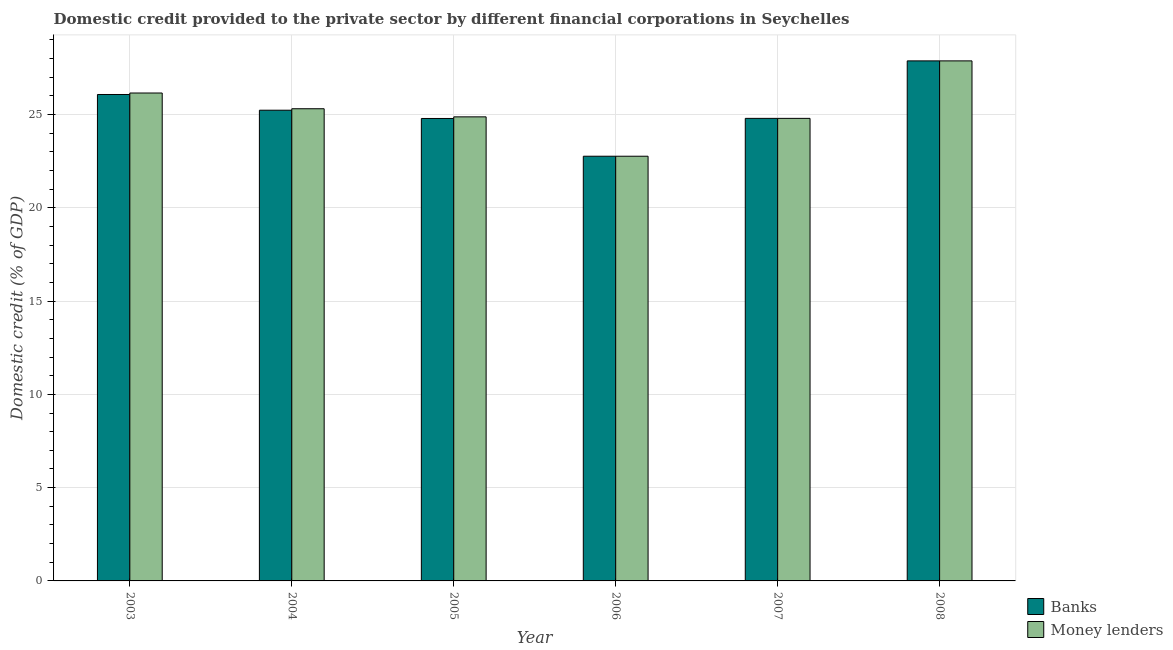How many different coloured bars are there?
Provide a succinct answer. 2. How many groups of bars are there?
Provide a succinct answer. 6. Are the number of bars per tick equal to the number of legend labels?
Your answer should be very brief. Yes. Are the number of bars on each tick of the X-axis equal?
Your answer should be compact. Yes. What is the domestic credit provided by banks in 2007?
Your answer should be compact. 24.79. Across all years, what is the maximum domestic credit provided by money lenders?
Keep it short and to the point. 27.88. Across all years, what is the minimum domestic credit provided by banks?
Your answer should be very brief. 22.76. In which year was the domestic credit provided by banks maximum?
Provide a short and direct response. 2008. In which year was the domestic credit provided by money lenders minimum?
Give a very brief answer. 2006. What is the total domestic credit provided by money lenders in the graph?
Make the answer very short. 151.77. What is the difference between the domestic credit provided by money lenders in 2005 and that in 2006?
Give a very brief answer. 2.11. What is the difference between the domestic credit provided by money lenders in 2006 and the domestic credit provided by banks in 2004?
Offer a very short reply. -2.55. What is the average domestic credit provided by banks per year?
Keep it short and to the point. 25.25. In the year 2004, what is the difference between the domestic credit provided by banks and domestic credit provided by money lenders?
Provide a succinct answer. 0. In how many years, is the domestic credit provided by money lenders greater than 7 %?
Your answer should be very brief. 6. What is the ratio of the domestic credit provided by banks in 2006 to that in 2007?
Your answer should be very brief. 0.92. Is the domestic credit provided by banks in 2006 less than that in 2008?
Give a very brief answer. Yes. What is the difference between the highest and the second highest domestic credit provided by money lenders?
Provide a short and direct response. 1.72. What is the difference between the highest and the lowest domestic credit provided by banks?
Make the answer very short. 5.11. Is the sum of the domestic credit provided by money lenders in 2004 and 2006 greater than the maximum domestic credit provided by banks across all years?
Give a very brief answer. Yes. What does the 1st bar from the left in 2003 represents?
Ensure brevity in your answer.  Banks. What does the 2nd bar from the right in 2003 represents?
Provide a short and direct response. Banks. Are the values on the major ticks of Y-axis written in scientific E-notation?
Make the answer very short. No. How many legend labels are there?
Provide a short and direct response. 2. What is the title of the graph?
Your response must be concise. Domestic credit provided to the private sector by different financial corporations in Seychelles. What is the label or title of the X-axis?
Make the answer very short. Year. What is the label or title of the Y-axis?
Ensure brevity in your answer.  Domestic credit (% of GDP). What is the Domestic credit (% of GDP) of Banks in 2003?
Offer a terse response. 26.07. What is the Domestic credit (% of GDP) of Money lenders in 2003?
Your answer should be very brief. 26.15. What is the Domestic credit (% of GDP) in Banks in 2004?
Give a very brief answer. 25.23. What is the Domestic credit (% of GDP) of Money lenders in 2004?
Your response must be concise. 25.31. What is the Domestic credit (% of GDP) in Banks in 2005?
Offer a very short reply. 24.79. What is the Domestic credit (% of GDP) in Money lenders in 2005?
Provide a succinct answer. 24.88. What is the Domestic credit (% of GDP) in Banks in 2006?
Offer a very short reply. 22.76. What is the Domestic credit (% of GDP) in Money lenders in 2006?
Offer a very short reply. 22.76. What is the Domestic credit (% of GDP) of Banks in 2007?
Your response must be concise. 24.79. What is the Domestic credit (% of GDP) in Money lenders in 2007?
Your response must be concise. 24.79. What is the Domestic credit (% of GDP) in Banks in 2008?
Keep it short and to the point. 27.88. What is the Domestic credit (% of GDP) of Money lenders in 2008?
Keep it short and to the point. 27.88. Across all years, what is the maximum Domestic credit (% of GDP) of Banks?
Give a very brief answer. 27.88. Across all years, what is the maximum Domestic credit (% of GDP) of Money lenders?
Provide a succinct answer. 27.88. Across all years, what is the minimum Domestic credit (% of GDP) of Banks?
Your answer should be very brief. 22.76. Across all years, what is the minimum Domestic credit (% of GDP) of Money lenders?
Give a very brief answer. 22.76. What is the total Domestic credit (% of GDP) in Banks in the graph?
Provide a short and direct response. 151.53. What is the total Domestic credit (% of GDP) in Money lenders in the graph?
Make the answer very short. 151.77. What is the difference between the Domestic credit (% of GDP) of Banks in 2003 and that in 2004?
Your answer should be very brief. 0.84. What is the difference between the Domestic credit (% of GDP) of Money lenders in 2003 and that in 2004?
Offer a terse response. 0.84. What is the difference between the Domestic credit (% of GDP) in Banks in 2003 and that in 2005?
Offer a terse response. 1.29. What is the difference between the Domestic credit (% of GDP) of Money lenders in 2003 and that in 2005?
Provide a succinct answer. 1.28. What is the difference between the Domestic credit (% of GDP) of Banks in 2003 and that in 2006?
Your response must be concise. 3.31. What is the difference between the Domestic credit (% of GDP) in Money lenders in 2003 and that in 2006?
Make the answer very short. 3.39. What is the difference between the Domestic credit (% of GDP) in Banks in 2003 and that in 2007?
Offer a very short reply. 1.28. What is the difference between the Domestic credit (% of GDP) of Money lenders in 2003 and that in 2007?
Your answer should be compact. 1.36. What is the difference between the Domestic credit (% of GDP) of Banks in 2003 and that in 2008?
Keep it short and to the point. -1.8. What is the difference between the Domestic credit (% of GDP) of Money lenders in 2003 and that in 2008?
Your answer should be compact. -1.72. What is the difference between the Domestic credit (% of GDP) in Banks in 2004 and that in 2005?
Your answer should be compact. 0.44. What is the difference between the Domestic credit (% of GDP) in Money lenders in 2004 and that in 2005?
Provide a succinct answer. 0.43. What is the difference between the Domestic credit (% of GDP) of Banks in 2004 and that in 2006?
Offer a terse response. 2.47. What is the difference between the Domestic credit (% of GDP) of Money lenders in 2004 and that in 2006?
Offer a very short reply. 2.55. What is the difference between the Domestic credit (% of GDP) of Banks in 2004 and that in 2007?
Ensure brevity in your answer.  0.44. What is the difference between the Domestic credit (% of GDP) of Money lenders in 2004 and that in 2007?
Your answer should be compact. 0.52. What is the difference between the Domestic credit (% of GDP) in Banks in 2004 and that in 2008?
Provide a short and direct response. -2.64. What is the difference between the Domestic credit (% of GDP) in Money lenders in 2004 and that in 2008?
Provide a succinct answer. -2.57. What is the difference between the Domestic credit (% of GDP) of Banks in 2005 and that in 2006?
Offer a very short reply. 2.02. What is the difference between the Domestic credit (% of GDP) in Money lenders in 2005 and that in 2006?
Your answer should be compact. 2.11. What is the difference between the Domestic credit (% of GDP) of Banks in 2005 and that in 2007?
Provide a short and direct response. -0.01. What is the difference between the Domestic credit (% of GDP) of Money lenders in 2005 and that in 2007?
Keep it short and to the point. 0.08. What is the difference between the Domestic credit (% of GDP) of Banks in 2005 and that in 2008?
Provide a succinct answer. -3.09. What is the difference between the Domestic credit (% of GDP) of Money lenders in 2005 and that in 2008?
Keep it short and to the point. -3. What is the difference between the Domestic credit (% of GDP) of Banks in 2006 and that in 2007?
Offer a very short reply. -2.03. What is the difference between the Domestic credit (% of GDP) in Money lenders in 2006 and that in 2007?
Keep it short and to the point. -2.03. What is the difference between the Domestic credit (% of GDP) of Banks in 2006 and that in 2008?
Keep it short and to the point. -5.11. What is the difference between the Domestic credit (% of GDP) in Money lenders in 2006 and that in 2008?
Give a very brief answer. -5.11. What is the difference between the Domestic credit (% of GDP) of Banks in 2007 and that in 2008?
Your response must be concise. -3.08. What is the difference between the Domestic credit (% of GDP) of Money lenders in 2007 and that in 2008?
Keep it short and to the point. -3.08. What is the difference between the Domestic credit (% of GDP) in Banks in 2003 and the Domestic credit (% of GDP) in Money lenders in 2004?
Keep it short and to the point. 0.76. What is the difference between the Domestic credit (% of GDP) in Banks in 2003 and the Domestic credit (% of GDP) in Money lenders in 2005?
Offer a very short reply. 1.2. What is the difference between the Domestic credit (% of GDP) of Banks in 2003 and the Domestic credit (% of GDP) of Money lenders in 2006?
Provide a succinct answer. 3.31. What is the difference between the Domestic credit (% of GDP) of Banks in 2003 and the Domestic credit (% of GDP) of Money lenders in 2007?
Provide a succinct answer. 1.28. What is the difference between the Domestic credit (% of GDP) of Banks in 2003 and the Domestic credit (% of GDP) of Money lenders in 2008?
Ensure brevity in your answer.  -1.8. What is the difference between the Domestic credit (% of GDP) in Banks in 2004 and the Domestic credit (% of GDP) in Money lenders in 2005?
Provide a short and direct response. 0.36. What is the difference between the Domestic credit (% of GDP) of Banks in 2004 and the Domestic credit (% of GDP) of Money lenders in 2006?
Provide a succinct answer. 2.47. What is the difference between the Domestic credit (% of GDP) of Banks in 2004 and the Domestic credit (% of GDP) of Money lenders in 2007?
Your answer should be compact. 0.44. What is the difference between the Domestic credit (% of GDP) in Banks in 2004 and the Domestic credit (% of GDP) in Money lenders in 2008?
Ensure brevity in your answer.  -2.64. What is the difference between the Domestic credit (% of GDP) of Banks in 2005 and the Domestic credit (% of GDP) of Money lenders in 2006?
Ensure brevity in your answer.  2.02. What is the difference between the Domestic credit (% of GDP) in Banks in 2005 and the Domestic credit (% of GDP) in Money lenders in 2007?
Your response must be concise. -0.01. What is the difference between the Domestic credit (% of GDP) of Banks in 2005 and the Domestic credit (% of GDP) of Money lenders in 2008?
Make the answer very short. -3.09. What is the difference between the Domestic credit (% of GDP) in Banks in 2006 and the Domestic credit (% of GDP) in Money lenders in 2007?
Provide a short and direct response. -2.03. What is the difference between the Domestic credit (% of GDP) of Banks in 2006 and the Domestic credit (% of GDP) of Money lenders in 2008?
Make the answer very short. -5.11. What is the difference between the Domestic credit (% of GDP) of Banks in 2007 and the Domestic credit (% of GDP) of Money lenders in 2008?
Your response must be concise. -3.08. What is the average Domestic credit (% of GDP) in Banks per year?
Keep it short and to the point. 25.25. What is the average Domestic credit (% of GDP) of Money lenders per year?
Make the answer very short. 25.3. In the year 2003, what is the difference between the Domestic credit (% of GDP) in Banks and Domestic credit (% of GDP) in Money lenders?
Your answer should be very brief. -0.08. In the year 2004, what is the difference between the Domestic credit (% of GDP) of Banks and Domestic credit (% of GDP) of Money lenders?
Provide a short and direct response. -0.08. In the year 2005, what is the difference between the Domestic credit (% of GDP) in Banks and Domestic credit (% of GDP) in Money lenders?
Ensure brevity in your answer.  -0.09. What is the ratio of the Domestic credit (% of GDP) of Banks in 2003 to that in 2004?
Ensure brevity in your answer.  1.03. What is the ratio of the Domestic credit (% of GDP) in Money lenders in 2003 to that in 2004?
Provide a succinct answer. 1.03. What is the ratio of the Domestic credit (% of GDP) in Banks in 2003 to that in 2005?
Offer a terse response. 1.05. What is the ratio of the Domestic credit (% of GDP) of Money lenders in 2003 to that in 2005?
Offer a very short reply. 1.05. What is the ratio of the Domestic credit (% of GDP) of Banks in 2003 to that in 2006?
Give a very brief answer. 1.15. What is the ratio of the Domestic credit (% of GDP) of Money lenders in 2003 to that in 2006?
Ensure brevity in your answer.  1.15. What is the ratio of the Domestic credit (% of GDP) of Banks in 2003 to that in 2007?
Keep it short and to the point. 1.05. What is the ratio of the Domestic credit (% of GDP) of Money lenders in 2003 to that in 2007?
Your answer should be very brief. 1.05. What is the ratio of the Domestic credit (% of GDP) of Banks in 2003 to that in 2008?
Your answer should be compact. 0.94. What is the ratio of the Domestic credit (% of GDP) of Money lenders in 2003 to that in 2008?
Keep it short and to the point. 0.94. What is the ratio of the Domestic credit (% of GDP) in Banks in 2004 to that in 2005?
Make the answer very short. 1.02. What is the ratio of the Domestic credit (% of GDP) of Money lenders in 2004 to that in 2005?
Your answer should be very brief. 1.02. What is the ratio of the Domestic credit (% of GDP) of Banks in 2004 to that in 2006?
Provide a succinct answer. 1.11. What is the ratio of the Domestic credit (% of GDP) of Money lenders in 2004 to that in 2006?
Make the answer very short. 1.11. What is the ratio of the Domestic credit (% of GDP) of Banks in 2004 to that in 2007?
Give a very brief answer. 1.02. What is the ratio of the Domestic credit (% of GDP) of Money lenders in 2004 to that in 2007?
Provide a short and direct response. 1.02. What is the ratio of the Domestic credit (% of GDP) in Banks in 2004 to that in 2008?
Your answer should be compact. 0.91. What is the ratio of the Domestic credit (% of GDP) of Money lenders in 2004 to that in 2008?
Provide a succinct answer. 0.91. What is the ratio of the Domestic credit (% of GDP) of Banks in 2005 to that in 2006?
Offer a terse response. 1.09. What is the ratio of the Domestic credit (% of GDP) in Money lenders in 2005 to that in 2006?
Provide a short and direct response. 1.09. What is the ratio of the Domestic credit (% of GDP) of Banks in 2005 to that in 2008?
Ensure brevity in your answer.  0.89. What is the ratio of the Domestic credit (% of GDP) in Money lenders in 2005 to that in 2008?
Keep it short and to the point. 0.89. What is the ratio of the Domestic credit (% of GDP) in Banks in 2006 to that in 2007?
Provide a short and direct response. 0.92. What is the ratio of the Domestic credit (% of GDP) of Money lenders in 2006 to that in 2007?
Provide a short and direct response. 0.92. What is the ratio of the Domestic credit (% of GDP) in Banks in 2006 to that in 2008?
Give a very brief answer. 0.82. What is the ratio of the Domestic credit (% of GDP) in Money lenders in 2006 to that in 2008?
Ensure brevity in your answer.  0.82. What is the ratio of the Domestic credit (% of GDP) of Banks in 2007 to that in 2008?
Ensure brevity in your answer.  0.89. What is the ratio of the Domestic credit (% of GDP) of Money lenders in 2007 to that in 2008?
Your response must be concise. 0.89. What is the difference between the highest and the second highest Domestic credit (% of GDP) of Banks?
Make the answer very short. 1.8. What is the difference between the highest and the second highest Domestic credit (% of GDP) in Money lenders?
Make the answer very short. 1.72. What is the difference between the highest and the lowest Domestic credit (% of GDP) in Banks?
Ensure brevity in your answer.  5.11. What is the difference between the highest and the lowest Domestic credit (% of GDP) in Money lenders?
Provide a succinct answer. 5.11. 